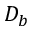<formula> <loc_0><loc_0><loc_500><loc_500>D _ { b }</formula> 